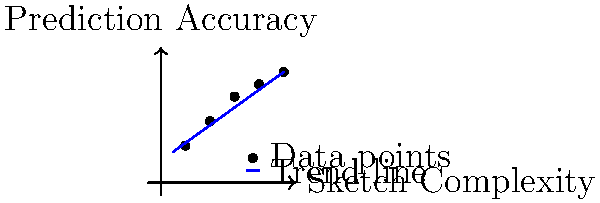As a fashion illustrator collaborating with students, you're exploring machine learning applications in your field. The graph shows the relationship between sketch complexity and prediction accuracy for a garment measurement prediction model. Based on the trend line, what would be the expected prediction accuracy for a sketch with a complexity level of 7? To solve this problem, we need to follow these steps:

1. Observe the trend line (blue) in the graph, which represents the relationship between sketch complexity and prediction accuracy.

2. The trend line appears to be linear, suggesting a positive correlation between sketch complexity and prediction accuracy.

3. To find the expected prediction accuracy for a sketch complexity of 7, we need to estimate the y-value on the trend line corresponding to x = 7.

4. We can use two points on the line to calculate the slope and y-intercept:
   Point 1: (1, 2.5)
   Point 2: (10, 9)

5. Calculate the slope:
   $m = \frac{y_2 - y_1}{x_2 - x_1} = \frac{9 - 2.5}{10 - 1} = \frac{6.5}{9} \approx 0.72$

6. Use the point-slope form of a line to find the y-intercept:
   $y - y_1 = m(x - x_1)$
   $y - 2.5 = 0.72(x - 1)$
   $y = 0.72x + 1.78$

7. Now we can calculate the expected prediction accuracy for x = 7:
   $y = 0.72(7) + 1.78 = 5.04 + 1.78 = 6.82$

8. Round to the nearest whole number: 7

Therefore, the expected prediction accuracy for a sketch with a complexity level of 7 is approximately 7.
Answer: 7 